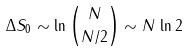<formula> <loc_0><loc_0><loc_500><loc_500>\Delta S _ { 0 } \sim \ln \binom { N } { N / 2 } \sim N \, \ln 2</formula> 